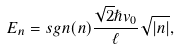Convert formula to latex. <formula><loc_0><loc_0><loc_500><loc_500>E _ { n } = s g n ( n ) \frac { \sqrt { 2 } \hslash v _ { 0 } } { \ell } \sqrt { \left | n \right | } ,</formula> 